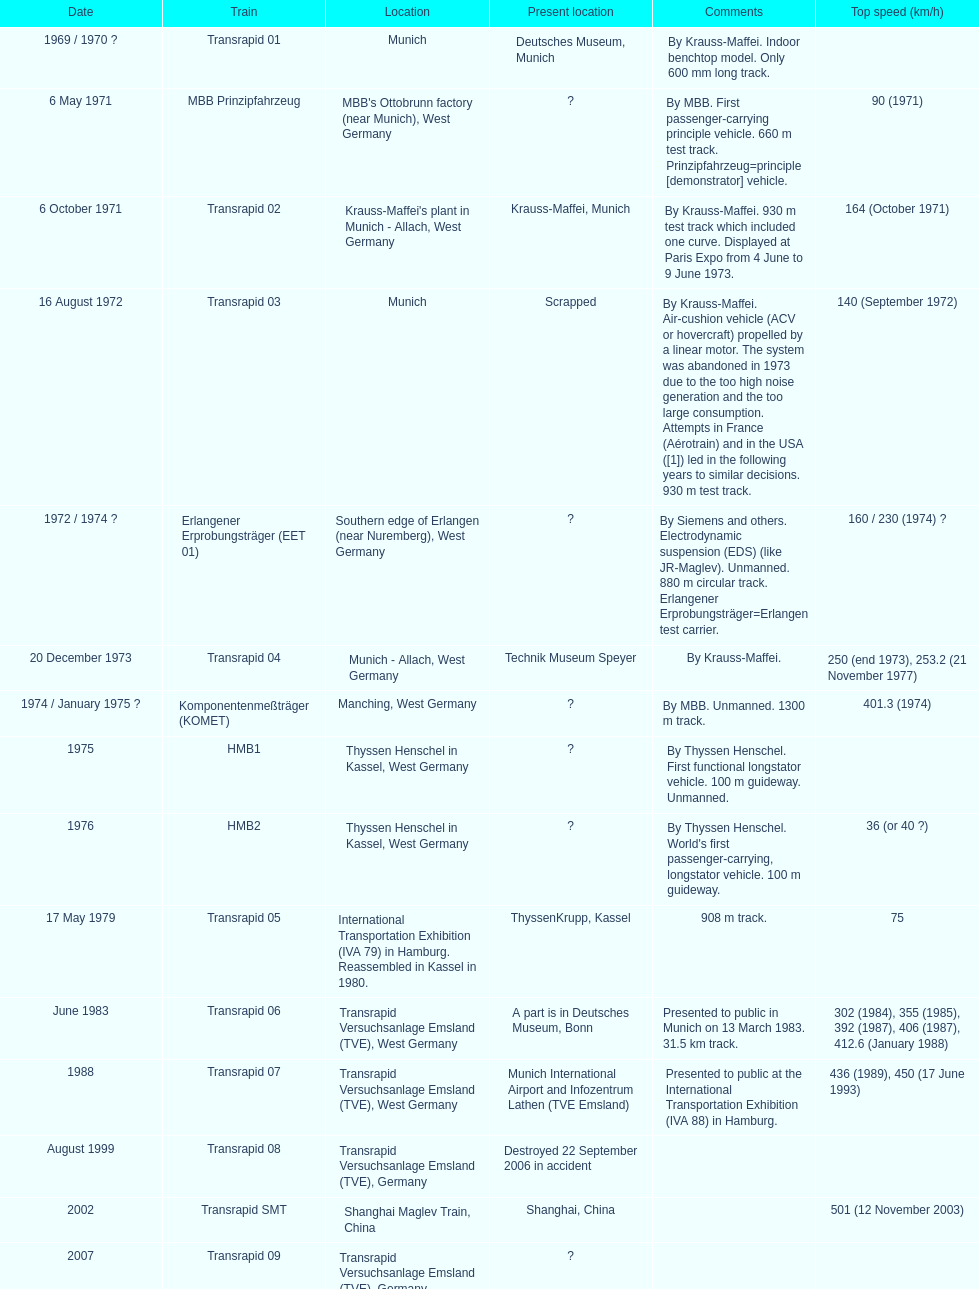Which train has the least top speed? HMB2. 